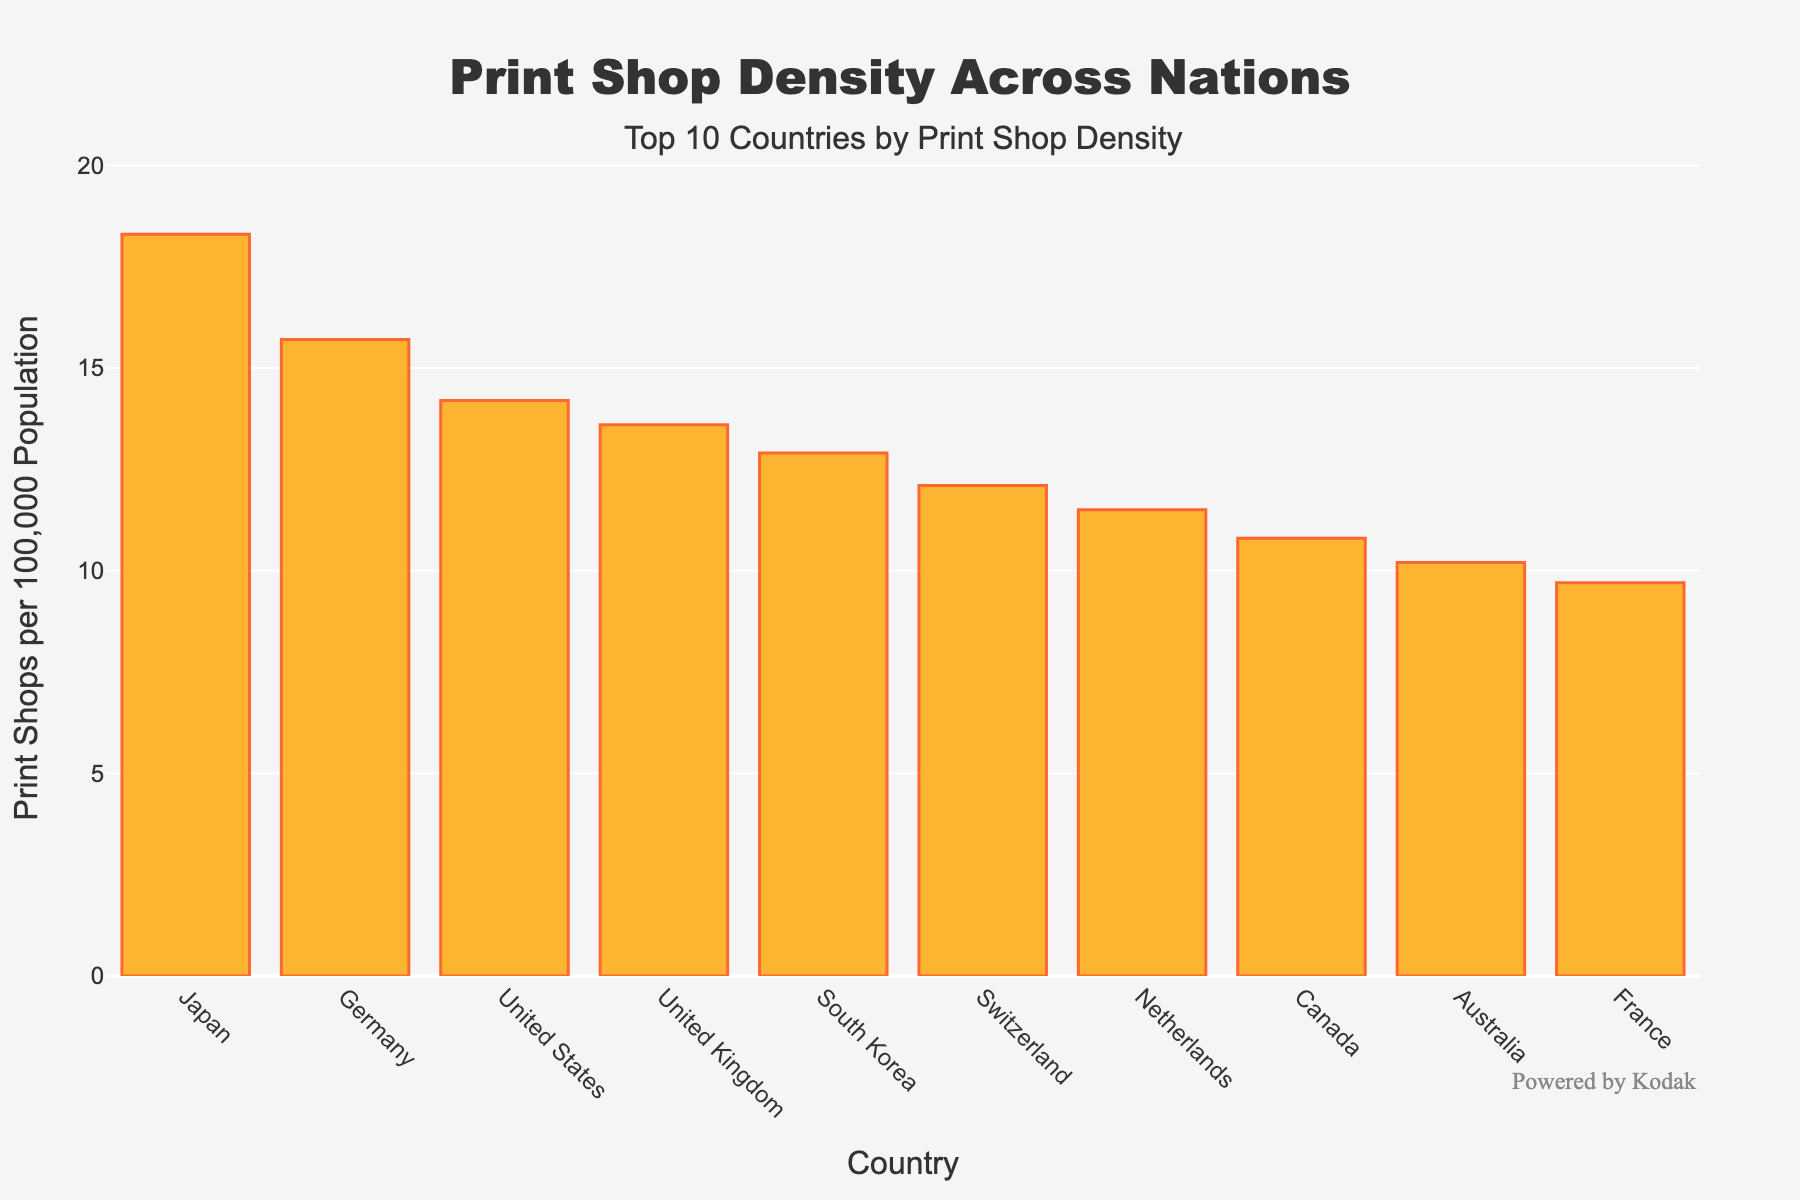What's the country with the highest print shop density? To find the country with the highest print shop density, observe the bar with the greatest height. In the chart, the tallest bar corresponds to Japan.
Answer: Japan Which country has the second-highest print shop density? Identify the second tallest bar in the chart. The second highest bar corresponds to Germany.
Answer: Germany What's the difference in print shop density between Japan and France? Locate the bars for Japan and France, then subtract the height of France's bar from Japan's. Japan has 18.3 and France has 9.7. So, 18.3 - 9.7 = 8.6.
Answer: 8.6 Which country has a lower print shop density, Canada or Australia? Compare the heights of Canada’s and Australia’s bars. Since Canada has 10.8 and Australia has 10.2, Australia has a lower density.
Answer: Australia What is the average print shop density for the top 3 countries? Sum the print shop density values for the top 3 countries (Japan: 18.3, Germany: 15.7, United States: 14.2) then divide by 3. (18.3 + 15.7 + 14.2) / 3 = 16.067.
Answer: 16.067 What is the sum of the print shop densities for the United Kingdom and Switzerland? Add the print shop densities for the United Kingdom (13.6) and Switzerland (12.1). 13.6 + 12.1 = 25.7.
Answer: 25.7 Which number is higher: the print shop density of South Korea or the average density of Canada and the Netherlands? Compare the values. South Korea's print shop density is 12.9. The average density of Canada (10.8) and the Netherlands (11.5) is (10.8 + 11.5) / 2 = 11.15. 12.9 is higher than 11.15.
Answer: South Korea Which country has fewer print shops per 100k population, Switzerland or France? Compare the heights of Switzerland’s and France’s bars. Switzerland has 12.1, and France has 9.7. France has fewer print shops per 100k population.
Answer: France What is the difference in print shop density between the Netherlands and the United Kingdom? Subtract the print shop density of the Netherlands from that of the United Kingdom. United Kingdom has 13.6 and Netherlands has 11.5. So, 13.6 - 11.5 = 2.1.
Answer: 2.1 What's the combined print shop density of the bottom three countries on the list? Sum the print shop densities of the bottom three countries (Canada: 10.8, Australia: 10.2, France: 9.7). 10.8 + 10.2 + 9.7 = 30.7.
Answer: 30.7 